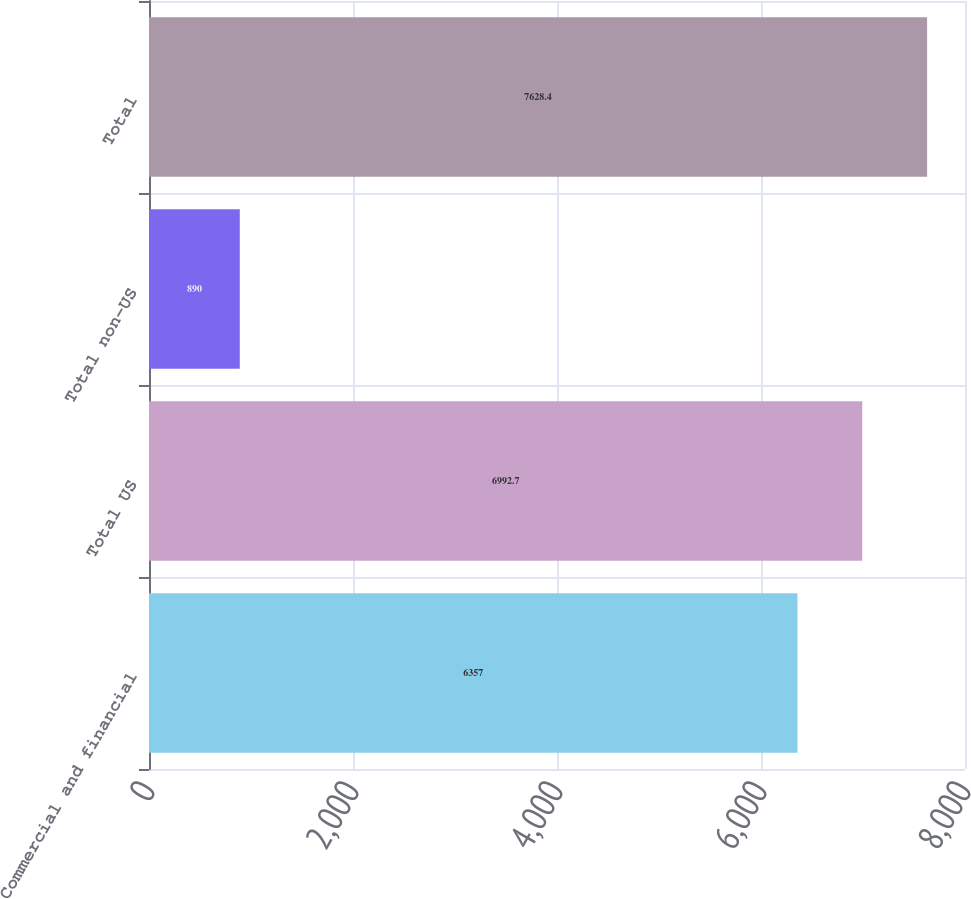Convert chart to OTSL. <chart><loc_0><loc_0><loc_500><loc_500><bar_chart><fcel>Commercial and financial<fcel>Total US<fcel>Total non-US<fcel>Total<nl><fcel>6357<fcel>6992.7<fcel>890<fcel>7628.4<nl></chart> 